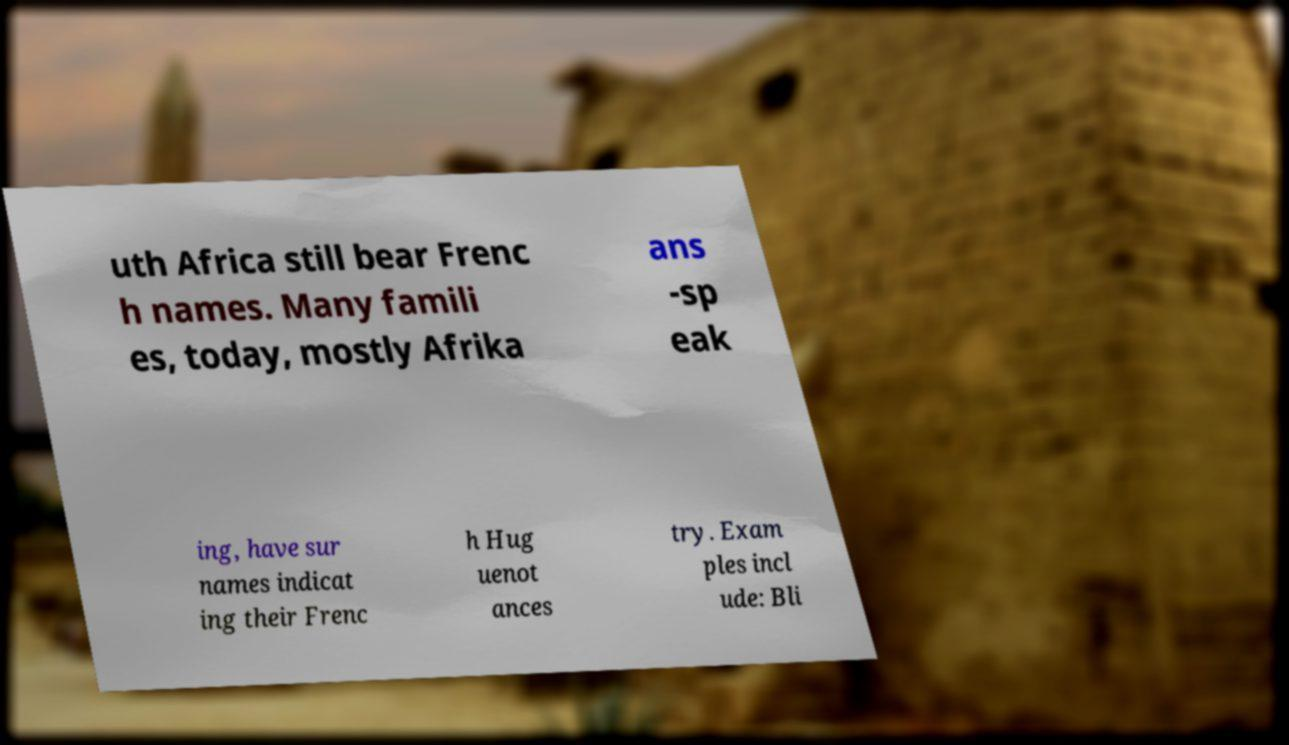There's text embedded in this image that I need extracted. Can you transcribe it verbatim? uth Africa still bear Frenc h names. Many famili es, today, mostly Afrika ans -sp eak ing, have sur names indicat ing their Frenc h Hug uenot ances try. Exam ples incl ude: Bli 